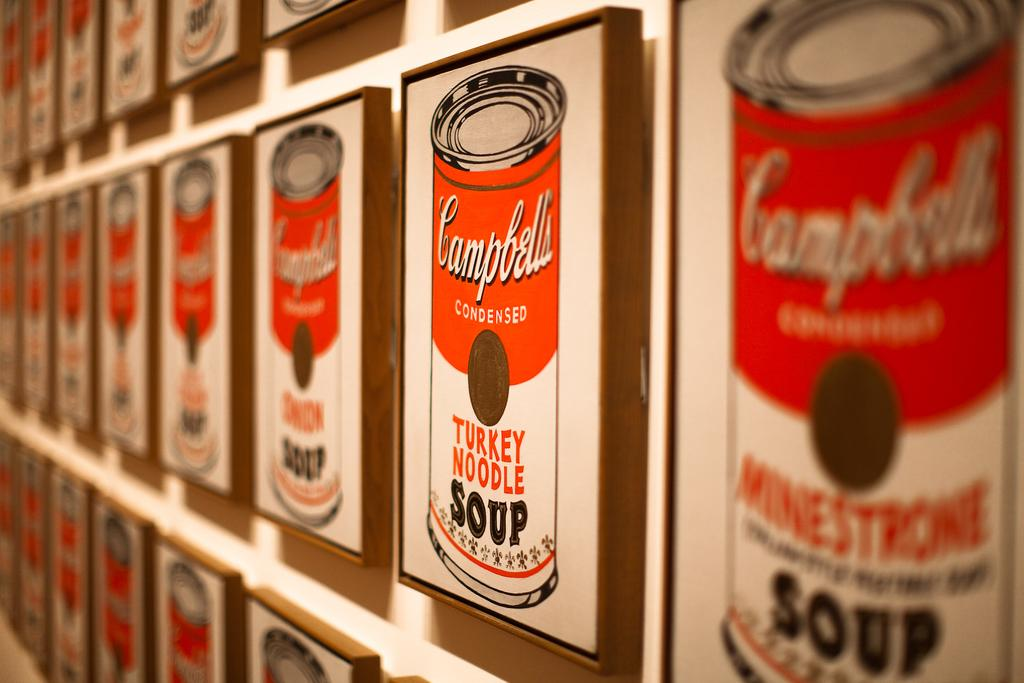Provide a one-sentence caption for the provided image. A wall of Campbell's turkey noodle soup patterns. 